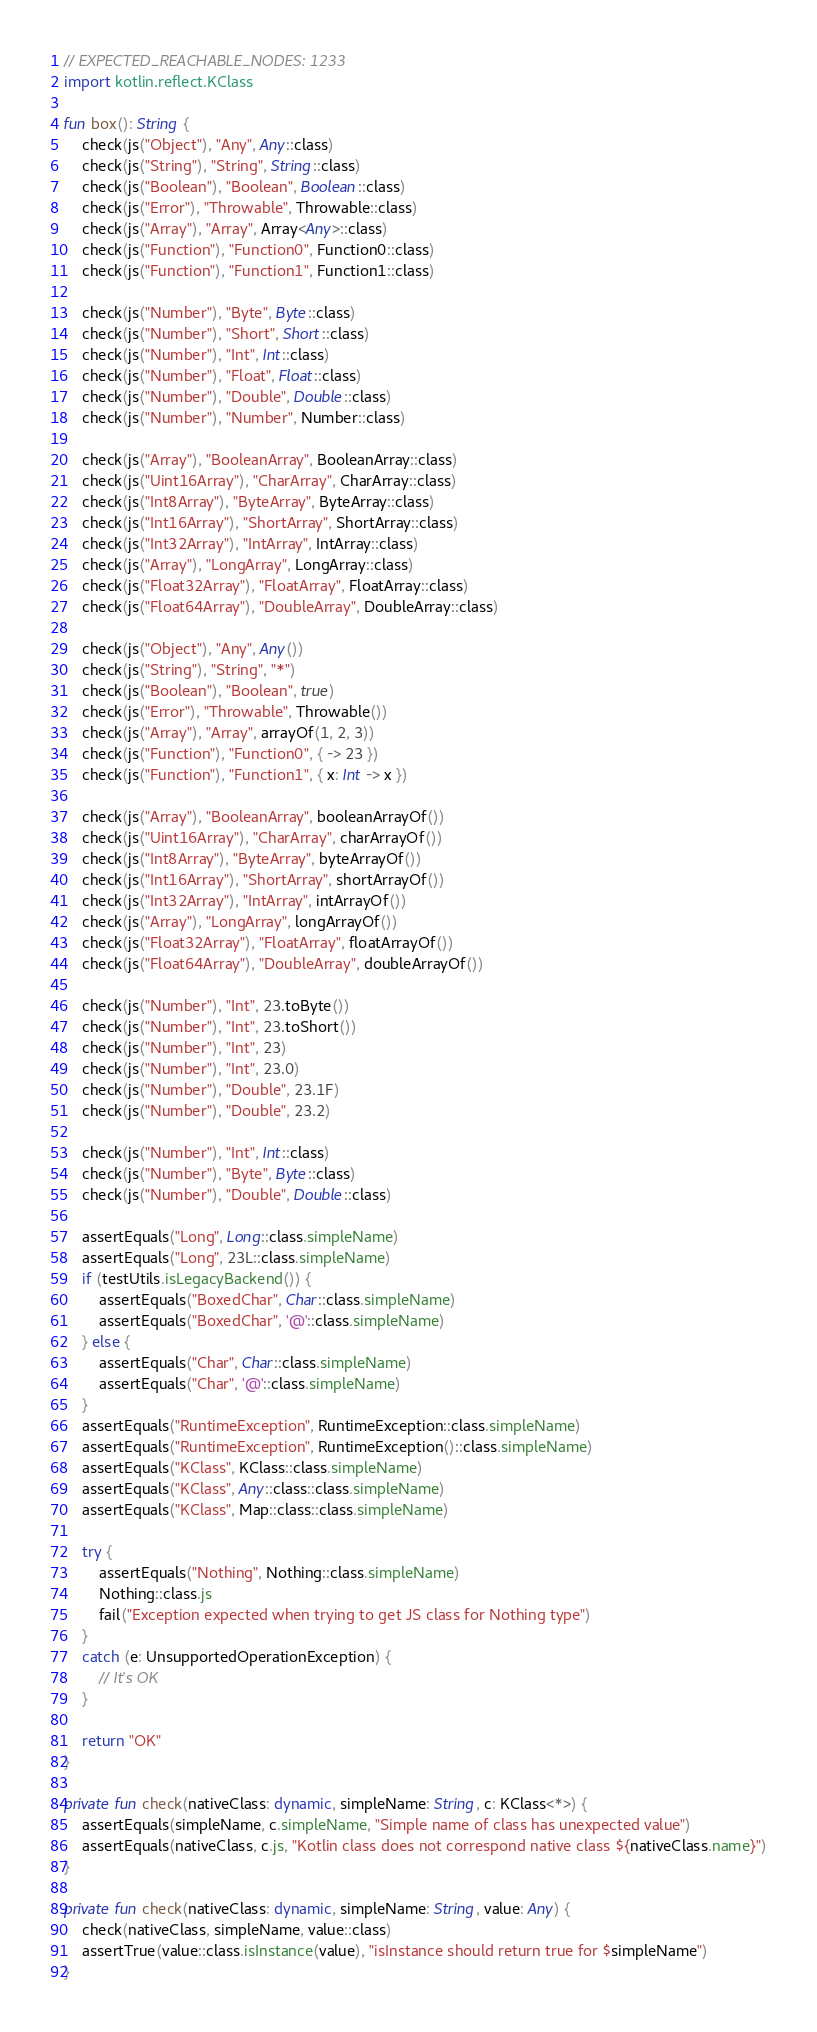Convert code to text. <code><loc_0><loc_0><loc_500><loc_500><_Kotlin_>// EXPECTED_REACHABLE_NODES: 1233
import kotlin.reflect.KClass

fun box(): String {
    check(js("Object"), "Any", Any::class)
    check(js("String"), "String", String::class)
    check(js("Boolean"), "Boolean", Boolean::class)
    check(js("Error"), "Throwable", Throwable::class)
    check(js("Array"), "Array", Array<Any>::class)
    check(js("Function"), "Function0", Function0::class)
    check(js("Function"), "Function1", Function1::class)

    check(js("Number"), "Byte", Byte::class)
    check(js("Number"), "Short", Short::class)
    check(js("Number"), "Int", Int::class)
    check(js("Number"), "Float", Float::class)
    check(js("Number"), "Double", Double::class)
    check(js("Number"), "Number", Number::class)

    check(js("Array"), "BooleanArray", BooleanArray::class)
    check(js("Uint16Array"), "CharArray", CharArray::class)
    check(js("Int8Array"), "ByteArray", ByteArray::class)
    check(js("Int16Array"), "ShortArray", ShortArray::class)
    check(js("Int32Array"), "IntArray", IntArray::class)
    check(js("Array"), "LongArray", LongArray::class)
    check(js("Float32Array"), "FloatArray", FloatArray::class)
    check(js("Float64Array"), "DoubleArray", DoubleArray::class)

    check(js("Object"), "Any", Any())
    check(js("String"), "String", "*")
    check(js("Boolean"), "Boolean", true)
    check(js("Error"), "Throwable", Throwable())
    check(js("Array"), "Array", arrayOf(1, 2, 3))
    check(js("Function"), "Function0", { -> 23 })
    check(js("Function"), "Function1", { x: Int -> x })

    check(js("Array"), "BooleanArray", booleanArrayOf())
    check(js("Uint16Array"), "CharArray", charArrayOf())
    check(js("Int8Array"), "ByteArray", byteArrayOf())
    check(js("Int16Array"), "ShortArray", shortArrayOf())
    check(js("Int32Array"), "IntArray", intArrayOf())
    check(js("Array"), "LongArray", longArrayOf())
    check(js("Float32Array"), "FloatArray", floatArrayOf())
    check(js("Float64Array"), "DoubleArray", doubleArrayOf())

    check(js("Number"), "Int", 23.toByte())
    check(js("Number"), "Int", 23.toShort())
    check(js("Number"), "Int", 23)
    check(js("Number"), "Int", 23.0)
    check(js("Number"), "Double", 23.1F)
    check(js("Number"), "Double", 23.2)

    check(js("Number"), "Int", Int::class)
    check(js("Number"), "Byte", Byte::class)
    check(js("Number"), "Double", Double::class)

    assertEquals("Long", Long::class.simpleName)
    assertEquals("Long", 23L::class.simpleName)
    if (testUtils.isLegacyBackend()) {
        assertEquals("BoxedChar", Char::class.simpleName)
        assertEquals("BoxedChar", '@'::class.simpleName)
    } else {
        assertEquals("Char", Char::class.simpleName)
        assertEquals("Char", '@'::class.simpleName)
    }
    assertEquals("RuntimeException", RuntimeException::class.simpleName)
    assertEquals("RuntimeException", RuntimeException()::class.simpleName)
    assertEquals("KClass", KClass::class.simpleName)
    assertEquals("KClass", Any::class::class.simpleName)
    assertEquals("KClass", Map::class::class.simpleName)

    try {
        assertEquals("Nothing", Nothing::class.simpleName)
        Nothing::class.js
        fail("Exception expected when trying to get JS class for Nothing type")
    }
    catch (e: UnsupportedOperationException) {
        // It's OK
    }

    return "OK"
}

private fun check(nativeClass: dynamic, simpleName: String, c: KClass<*>) {
    assertEquals(simpleName, c.simpleName, "Simple name of class has unexpected value")
    assertEquals(nativeClass, c.js, "Kotlin class does not correspond native class ${nativeClass.name}")
}

private fun check(nativeClass: dynamic, simpleName: String, value: Any) {
    check(nativeClass, simpleName, value::class)
    assertTrue(value::class.isInstance(value), "isInstance should return true for $simpleName")
}</code> 